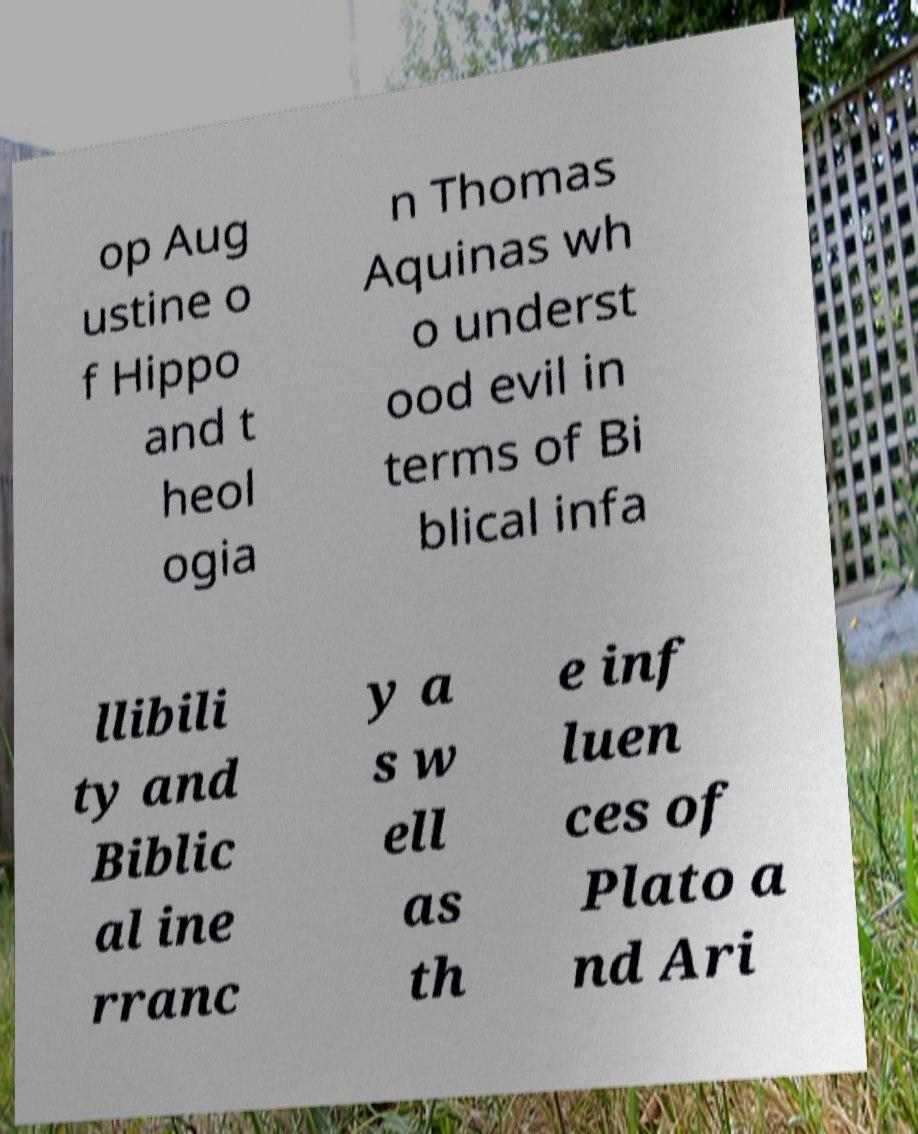What messages or text are displayed in this image? I need them in a readable, typed format. op Aug ustine o f Hippo and t heol ogia n Thomas Aquinas wh o underst ood evil in terms of Bi blical infa llibili ty and Biblic al ine rranc y a s w ell as th e inf luen ces of Plato a nd Ari 